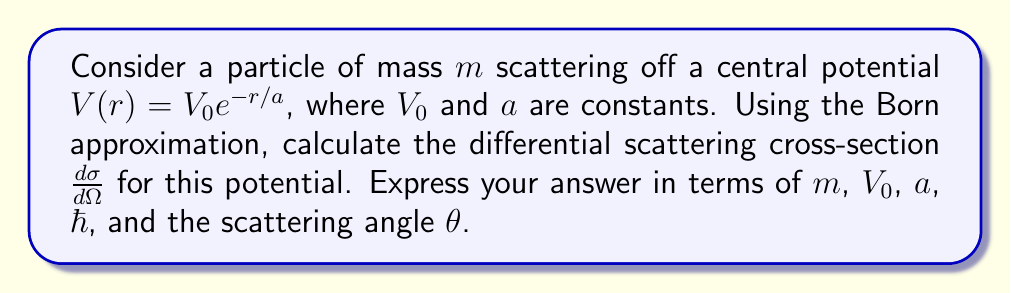Help me with this question. Let's approach this step-by-step:

1) In the Born approximation, the differential scattering cross-section is given by:

   $$\frac{d\sigma}{d\Omega} = \left(\frac{2m}{\hbar^2}\right)^2 |V(\mathbf{q})|^2$$

   where $V(\mathbf{q})$ is the Fourier transform of the potential $V(r)$.

2) We need to calculate $V(\mathbf{q})$:

   $$V(\mathbf{q}) = \int V(r) e^{i\mathbf{q}\cdot\mathbf{r}} d^3r$$

3) For a central potential, this becomes:

   $$V(\mathbf{q}) = 4\pi \int_0^\infty V(r) \frac{\sin(qr)}{qr} r^2 dr$$

4) Substituting our potential $V(r) = V_0 e^{-r/a}$:

   $$V(\mathbf{q}) = 4\pi V_0 \int_0^\infty e^{-r/a} \frac{\sin(qr)}{qr} r^2 dr$$

5) This integral can be evaluated to give:

   $$V(\mathbf{q}) = \frac{8\pi V_0 a^3}{(1 + q^2a^2)^2}$$

6) In elastic scattering, $q = 2k \sin(\theta/2)$, where $k$ is the wave number of the incident particle.

7) Substituting this into our expression for $V(\mathbf{q})$:

   $$V(\mathbf{q}) = \frac{8\pi V_0 a^3}{(1 + 4k^2a^2\sin^2(\theta/2))^2}$$

8) Now, we can substitute this into our original expression for the differential cross-section:

   $$\frac{d\sigma}{d\Omega} = \left(\frac{2m}{\hbar^2}\right)^2 \left(\frac{8\pi V_0 a^3}{(1 + 4k^2a^2\sin^2(\theta/2))^2}\right)^2$$

9) Finally, we need to express $k$ in terms of $m$. For a non-relativistic particle, $k = \frac{\sqrt{2mE}}{\hbar}$, where $E$ is the energy of the incident particle. However, we can leave it as $k$ in our final expression.
Answer: $$\frac{d\sigma}{d\Omega} = \frac{4m^2V_0^2a^6}{\hbar^4} \left(\frac{8\pi}{(1 + 4k^2a^2\sin^2(\theta/2))^2}\right)^2$$ 